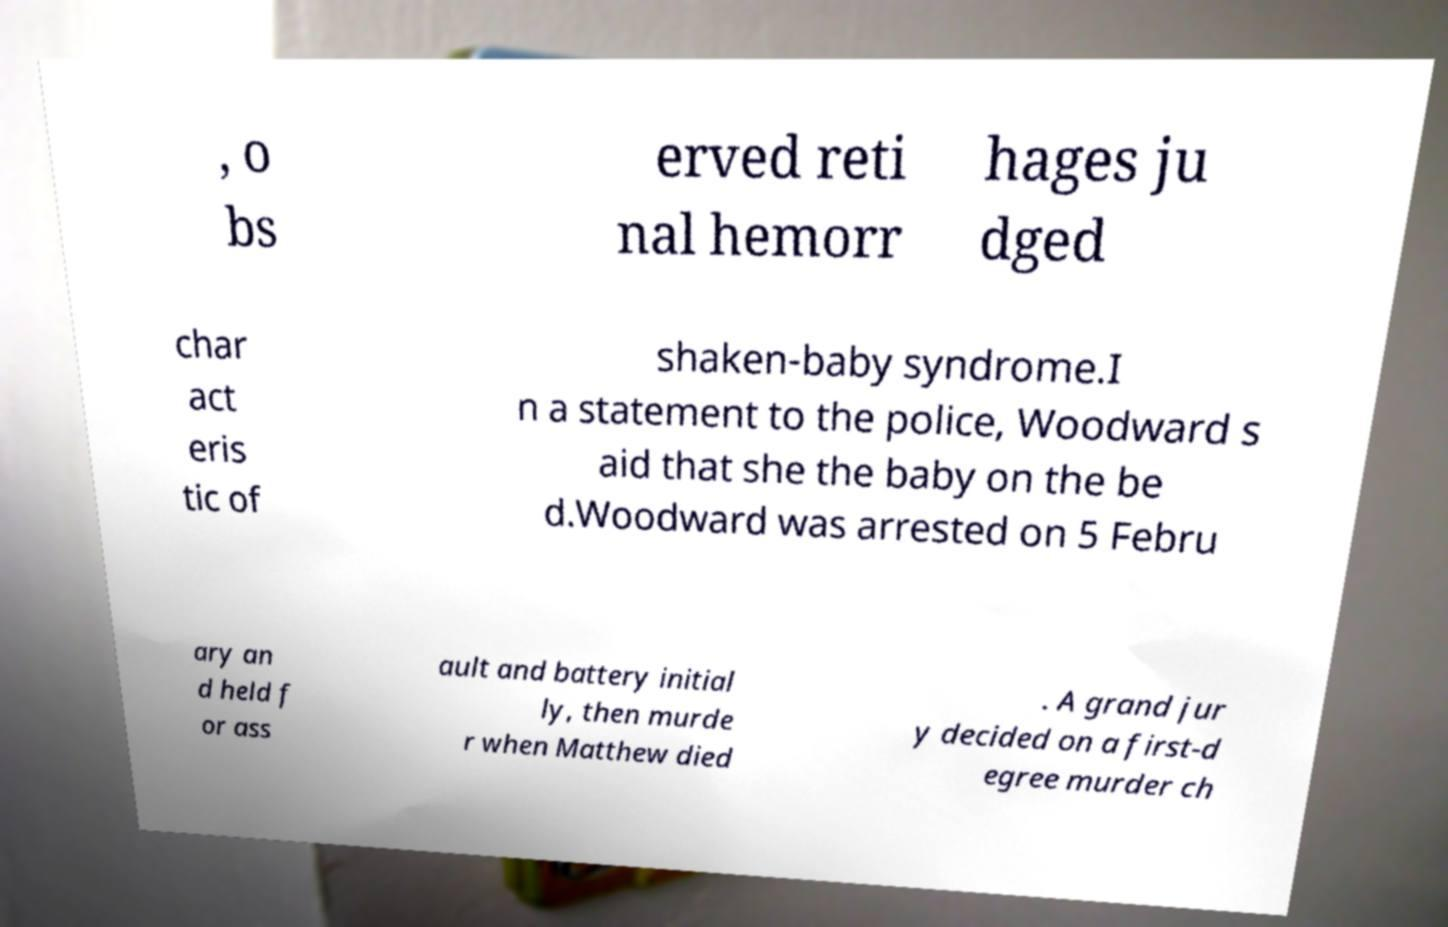Can you read and provide the text displayed in the image?This photo seems to have some interesting text. Can you extract and type it out for me? , o bs erved reti nal hemorr hages ju dged char act eris tic of shaken-baby syndrome.I n a statement to the police, Woodward s aid that she the baby on the be d.Woodward was arrested on 5 Febru ary an d held f or ass ault and battery initial ly, then murde r when Matthew died . A grand jur y decided on a first-d egree murder ch 